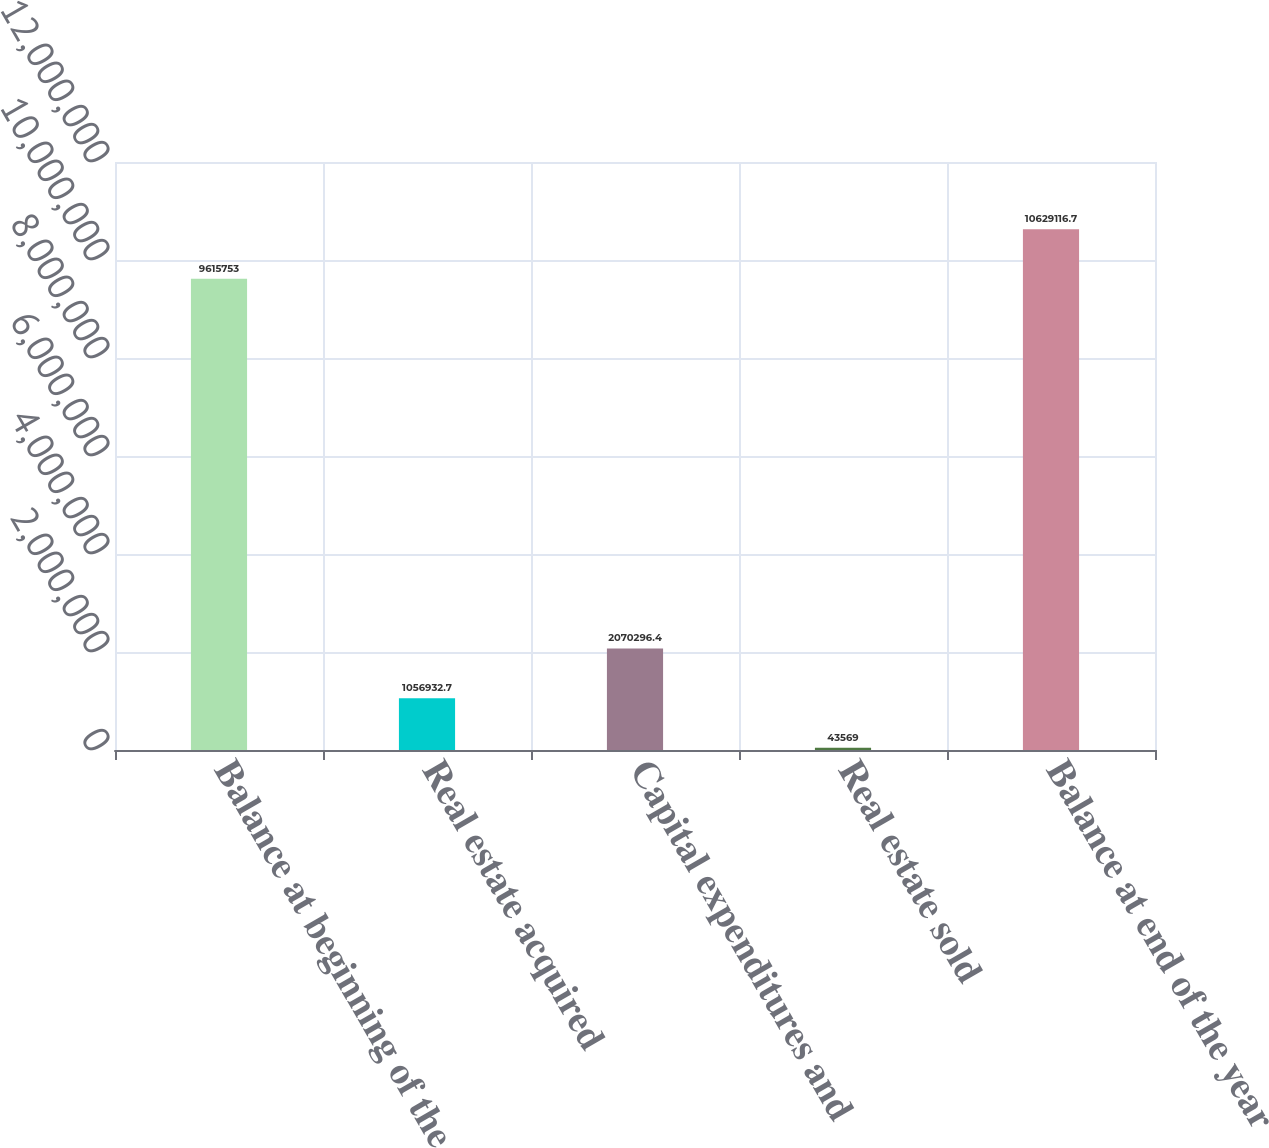Convert chart. <chart><loc_0><loc_0><loc_500><loc_500><bar_chart><fcel>Balance at beginning of the<fcel>Real estate acquired<fcel>Capital expenditures and<fcel>Real estate sold<fcel>Balance at end of the year<nl><fcel>9.61575e+06<fcel>1.05693e+06<fcel>2.0703e+06<fcel>43569<fcel>1.06291e+07<nl></chart> 